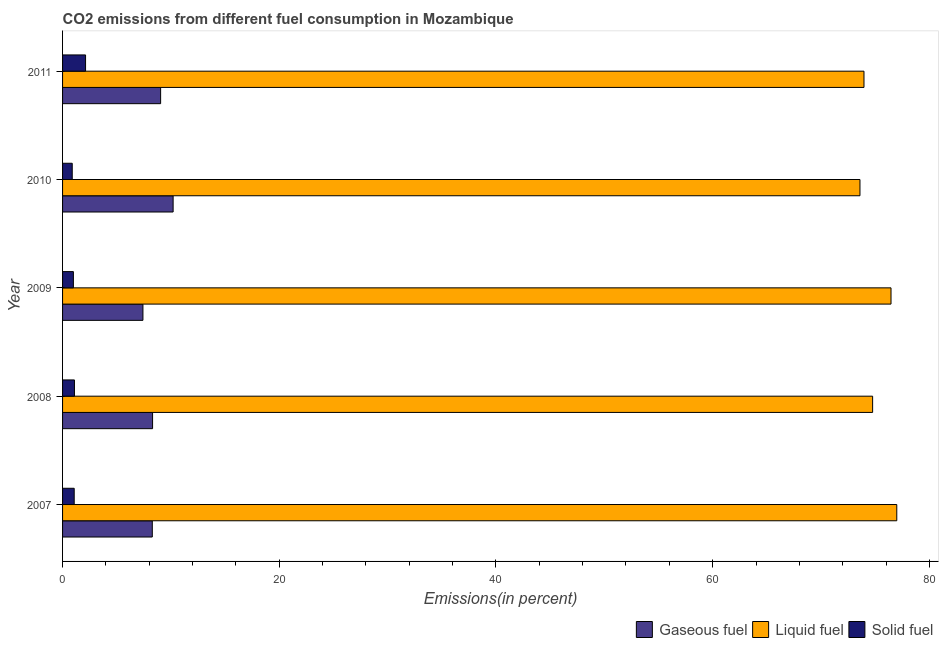Are the number of bars on each tick of the Y-axis equal?
Your answer should be compact. Yes. How many bars are there on the 3rd tick from the top?
Offer a very short reply. 3. How many bars are there on the 3rd tick from the bottom?
Make the answer very short. 3. What is the label of the 4th group of bars from the top?
Give a very brief answer. 2008. What is the percentage of solid fuel emission in 2007?
Provide a short and direct response. 1.07. Across all years, what is the maximum percentage of solid fuel emission?
Your answer should be very brief. 2.12. Across all years, what is the minimum percentage of solid fuel emission?
Ensure brevity in your answer.  0.89. In which year was the percentage of gaseous fuel emission maximum?
Offer a terse response. 2010. In which year was the percentage of solid fuel emission minimum?
Your answer should be compact. 2010. What is the total percentage of liquid fuel emission in the graph?
Your answer should be very brief. 375.78. What is the difference between the percentage of gaseous fuel emission in 2010 and that in 2011?
Offer a terse response. 1.15. What is the difference between the percentage of gaseous fuel emission in 2008 and the percentage of liquid fuel emission in 2011?
Provide a succinct answer. -65.66. What is the average percentage of gaseous fuel emission per year?
Offer a very short reply. 8.65. In the year 2009, what is the difference between the percentage of solid fuel emission and percentage of liquid fuel emission?
Offer a terse response. -75.46. What is the ratio of the percentage of solid fuel emission in 2009 to that in 2010?
Provide a short and direct response. 1.12. What is the difference between the highest and the second highest percentage of liquid fuel emission?
Make the answer very short. 0.53. What is the difference between the highest and the lowest percentage of gaseous fuel emission?
Ensure brevity in your answer.  2.79. In how many years, is the percentage of solid fuel emission greater than the average percentage of solid fuel emission taken over all years?
Your answer should be very brief. 1. What does the 2nd bar from the top in 2009 represents?
Offer a terse response. Liquid fuel. What does the 2nd bar from the bottom in 2008 represents?
Offer a very short reply. Liquid fuel. Are all the bars in the graph horizontal?
Offer a terse response. Yes. What is the difference between two consecutive major ticks on the X-axis?
Your response must be concise. 20. Are the values on the major ticks of X-axis written in scientific E-notation?
Give a very brief answer. No. Does the graph contain any zero values?
Make the answer very short. No. Does the graph contain grids?
Ensure brevity in your answer.  No. How many legend labels are there?
Offer a terse response. 3. What is the title of the graph?
Offer a terse response. CO2 emissions from different fuel consumption in Mozambique. Does "Taxes on goods and services" appear as one of the legend labels in the graph?
Provide a succinct answer. No. What is the label or title of the X-axis?
Your response must be concise. Emissions(in percent). What is the label or title of the Y-axis?
Provide a short and direct response. Year. What is the Emissions(in percent) in Gaseous fuel in 2007?
Offer a very short reply. 8.28. What is the Emissions(in percent) of Liquid fuel in 2007?
Offer a terse response. 76.99. What is the Emissions(in percent) in Solid fuel in 2007?
Offer a very short reply. 1.07. What is the Emissions(in percent) of Gaseous fuel in 2008?
Provide a short and direct response. 8.31. What is the Emissions(in percent) of Liquid fuel in 2008?
Offer a very short reply. 74.76. What is the Emissions(in percent) in Solid fuel in 2008?
Provide a succinct answer. 1.1. What is the Emissions(in percent) of Gaseous fuel in 2009?
Provide a succinct answer. 7.42. What is the Emissions(in percent) in Liquid fuel in 2009?
Provide a short and direct response. 76.46. What is the Emissions(in percent) in Solid fuel in 2009?
Your answer should be very brief. 1. What is the Emissions(in percent) of Gaseous fuel in 2010?
Ensure brevity in your answer.  10.2. What is the Emissions(in percent) in Liquid fuel in 2010?
Provide a short and direct response. 73.6. What is the Emissions(in percent) in Solid fuel in 2010?
Your answer should be compact. 0.89. What is the Emissions(in percent) in Gaseous fuel in 2011?
Your response must be concise. 9.05. What is the Emissions(in percent) of Liquid fuel in 2011?
Give a very brief answer. 73.97. What is the Emissions(in percent) in Solid fuel in 2011?
Offer a terse response. 2.12. Across all years, what is the maximum Emissions(in percent) of Gaseous fuel?
Your response must be concise. 10.2. Across all years, what is the maximum Emissions(in percent) in Liquid fuel?
Give a very brief answer. 76.99. Across all years, what is the maximum Emissions(in percent) of Solid fuel?
Make the answer very short. 2.12. Across all years, what is the minimum Emissions(in percent) in Gaseous fuel?
Provide a short and direct response. 7.42. Across all years, what is the minimum Emissions(in percent) in Liquid fuel?
Your answer should be compact. 73.6. Across all years, what is the minimum Emissions(in percent) in Solid fuel?
Provide a succinct answer. 0.89. What is the total Emissions(in percent) of Gaseous fuel in the graph?
Give a very brief answer. 43.26. What is the total Emissions(in percent) in Liquid fuel in the graph?
Your response must be concise. 375.78. What is the total Emissions(in percent) in Solid fuel in the graph?
Keep it short and to the point. 6.19. What is the difference between the Emissions(in percent) in Gaseous fuel in 2007 and that in 2008?
Make the answer very short. -0.03. What is the difference between the Emissions(in percent) of Liquid fuel in 2007 and that in 2008?
Offer a very short reply. 2.23. What is the difference between the Emissions(in percent) in Solid fuel in 2007 and that in 2008?
Provide a short and direct response. -0.02. What is the difference between the Emissions(in percent) in Gaseous fuel in 2007 and that in 2009?
Make the answer very short. 0.86. What is the difference between the Emissions(in percent) of Liquid fuel in 2007 and that in 2009?
Your response must be concise. 0.53. What is the difference between the Emissions(in percent) in Solid fuel in 2007 and that in 2009?
Keep it short and to the point. 0.07. What is the difference between the Emissions(in percent) in Gaseous fuel in 2007 and that in 2010?
Keep it short and to the point. -1.92. What is the difference between the Emissions(in percent) of Liquid fuel in 2007 and that in 2010?
Keep it short and to the point. 3.4. What is the difference between the Emissions(in percent) in Solid fuel in 2007 and that in 2010?
Make the answer very short. 0.18. What is the difference between the Emissions(in percent) of Gaseous fuel in 2007 and that in 2011?
Your answer should be compact. -0.77. What is the difference between the Emissions(in percent) of Liquid fuel in 2007 and that in 2011?
Provide a short and direct response. 3.03. What is the difference between the Emissions(in percent) in Solid fuel in 2007 and that in 2011?
Your answer should be very brief. -1.05. What is the difference between the Emissions(in percent) of Gaseous fuel in 2008 and that in 2009?
Make the answer very short. 0.89. What is the difference between the Emissions(in percent) of Liquid fuel in 2008 and that in 2009?
Your answer should be compact. -1.7. What is the difference between the Emissions(in percent) of Solid fuel in 2008 and that in 2009?
Offer a terse response. 0.1. What is the difference between the Emissions(in percent) in Gaseous fuel in 2008 and that in 2010?
Offer a terse response. -1.9. What is the difference between the Emissions(in percent) in Liquid fuel in 2008 and that in 2010?
Keep it short and to the point. 1.17. What is the difference between the Emissions(in percent) in Solid fuel in 2008 and that in 2010?
Provide a short and direct response. 0.2. What is the difference between the Emissions(in percent) of Gaseous fuel in 2008 and that in 2011?
Ensure brevity in your answer.  -0.74. What is the difference between the Emissions(in percent) in Liquid fuel in 2008 and that in 2011?
Keep it short and to the point. 0.8. What is the difference between the Emissions(in percent) of Solid fuel in 2008 and that in 2011?
Provide a short and direct response. -1.03. What is the difference between the Emissions(in percent) of Gaseous fuel in 2009 and that in 2010?
Your response must be concise. -2.79. What is the difference between the Emissions(in percent) in Liquid fuel in 2009 and that in 2010?
Offer a terse response. 2.87. What is the difference between the Emissions(in percent) of Solid fuel in 2009 and that in 2010?
Keep it short and to the point. 0.11. What is the difference between the Emissions(in percent) in Gaseous fuel in 2009 and that in 2011?
Keep it short and to the point. -1.63. What is the difference between the Emissions(in percent) in Liquid fuel in 2009 and that in 2011?
Keep it short and to the point. 2.5. What is the difference between the Emissions(in percent) of Solid fuel in 2009 and that in 2011?
Offer a terse response. -1.12. What is the difference between the Emissions(in percent) of Gaseous fuel in 2010 and that in 2011?
Offer a terse response. 1.15. What is the difference between the Emissions(in percent) of Liquid fuel in 2010 and that in 2011?
Your response must be concise. -0.37. What is the difference between the Emissions(in percent) in Solid fuel in 2010 and that in 2011?
Your answer should be compact. -1.23. What is the difference between the Emissions(in percent) of Gaseous fuel in 2007 and the Emissions(in percent) of Liquid fuel in 2008?
Keep it short and to the point. -66.48. What is the difference between the Emissions(in percent) of Gaseous fuel in 2007 and the Emissions(in percent) of Solid fuel in 2008?
Your answer should be very brief. 7.18. What is the difference between the Emissions(in percent) of Liquid fuel in 2007 and the Emissions(in percent) of Solid fuel in 2008?
Your answer should be compact. 75.9. What is the difference between the Emissions(in percent) in Gaseous fuel in 2007 and the Emissions(in percent) in Liquid fuel in 2009?
Offer a terse response. -68.18. What is the difference between the Emissions(in percent) in Gaseous fuel in 2007 and the Emissions(in percent) in Solid fuel in 2009?
Keep it short and to the point. 7.28. What is the difference between the Emissions(in percent) of Liquid fuel in 2007 and the Emissions(in percent) of Solid fuel in 2009?
Your answer should be very brief. 76. What is the difference between the Emissions(in percent) of Gaseous fuel in 2007 and the Emissions(in percent) of Liquid fuel in 2010?
Keep it short and to the point. -65.31. What is the difference between the Emissions(in percent) in Gaseous fuel in 2007 and the Emissions(in percent) in Solid fuel in 2010?
Make the answer very short. 7.39. What is the difference between the Emissions(in percent) of Liquid fuel in 2007 and the Emissions(in percent) of Solid fuel in 2010?
Offer a very short reply. 76.1. What is the difference between the Emissions(in percent) of Gaseous fuel in 2007 and the Emissions(in percent) of Liquid fuel in 2011?
Offer a very short reply. -65.68. What is the difference between the Emissions(in percent) in Gaseous fuel in 2007 and the Emissions(in percent) in Solid fuel in 2011?
Provide a short and direct response. 6.16. What is the difference between the Emissions(in percent) in Liquid fuel in 2007 and the Emissions(in percent) in Solid fuel in 2011?
Keep it short and to the point. 74.87. What is the difference between the Emissions(in percent) in Gaseous fuel in 2008 and the Emissions(in percent) in Liquid fuel in 2009?
Offer a very short reply. -68.16. What is the difference between the Emissions(in percent) of Gaseous fuel in 2008 and the Emissions(in percent) of Solid fuel in 2009?
Make the answer very short. 7.31. What is the difference between the Emissions(in percent) of Liquid fuel in 2008 and the Emissions(in percent) of Solid fuel in 2009?
Your response must be concise. 73.77. What is the difference between the Emissions(in percent) in Gaseous fuel in 2008 and the Emissions(in percent) in Liquid fuel in 2010?
Give a very brief answer. -65.29. What is the difference between the Emissions(in percent) of Gaseous fuel in 2008 and the Emissions(in percent) of Solid fuel in 2010?
Make the answer very short. 7.41. What is the difference between the Emissions(in percent) in Liquid fuel in 2008 and the Emissions(in percent) in Solid fuel in 2010?
Make the answer very short. 73.87. What is the difference between the Emissions(in percent) in Gaseous fuel in 2008 and the Emissions(in percent) in Liquid fuel in 2011?
Your response must be concise. -65.66. What is the difference between the Emissions(in percent) in Gaseous fuel in 2008 and the Emissions(in percent) in Solid fuel in 2011?
Keep it short and to the point. 6.18. What is the difference between the Emissions(in percent) of Liquid fuel in 2008 and the Emissions(in percent) of Solid fuel in 2011?
Ensure brevity in your answer.  72.64. What is the difference between the Emissions(in percent) in Gaseous fuel in 2009 and the Emissions(in percent) in Liquid fuel in 2010?
Offer a terse response. -66.18. What is the difference between the Emissions(in percent) in Gaseous fuel in 2009 and the Emissions(in percent) in Solid fuel in 2010?
Keep it short and to the point. 6.53. What is the difference between the Emissions(in percent) of Liquid fuel in 2009 and the Emissions(in percent) of Solid fuel in 2010?
Offer a terse response. 75.57. What is the difference between the Emissions(in percent) of Gaseous fuel in 2009 and the Emissions(in percent) of Liquid fuel in 2011?
Keep it short and to the point. -66.55. What is the difference between the Emissions(in percent) of Gaseous fuel in 2009 and the Emissions(in percent) of Solid fuel in 2011?
Ensure brevity in your answer.  5.3. What is the difference between the Emissions(in percent) in Liquid fuel in 2009 and the Emissions(in percent) in Solid fuel in 2011?
Offer a very short reply. 74.34. What is the difference between the Emissions(in percent) of Gaseous fuel in 2010 and the Emissions(in percent) of Liquid fuel in 2011?
Give a very brief answer. -63.76. What is the difference between the Emissions(in percent) of Gaseous fuel in 2010 and the Emissions(in percent) of Solid fuel in 2011?
Keep it short and to the point. 8.08. What is the difference between the Emissions(in percent) of Liquid fuel in 2010 and the Emissions(in percent) of Solid fuel in 2011?
Your answer should be very brief. 71.47. What is the average Emissions(in percent) in Gaseous fuel per year?
Your answer should be compact. 8.65. What is the average Emissions(in percent) in Liquid fuel per year?
Make the answer very short. 75.16. What is the average Emissions(in percent) in Solid fuel per year?
Keep it short and to the point. 1.24. In the year 2007, what is the difference between the Emissions(in percent) in Gaseous fuel and Emissions(in percent) in Liquid fuel?
Your response must be concise. -68.71. In the year 2007, what is the difference between the Emissions(in percent) in Gaseous fuel and Emissions(in percent) in Solid fuel?
Offer a very short reply. 7.21. In the year 2007, what is the difference between the Emissions(in percent) of Liquid fuel and Emissions(in percent) of Solid fuel?
Give a very brief answer. 75.92. In the year 2008, what is the difference between the Emissions(in percent) of Gaseous fuel and Emissions(in percent) of Liquid fuel?
Keep it short and to the point. -66.46. In the year 2008, what is the difference between the Emissions(in percent) in Gaseous fuel and Emissions(in percent) in Solid fuel?
Offer a very short reply. 7.21. In the year 2008, what is the difference between the Emissions(in percent) of Liquid fuel and Emissions(in percent) of Solid fuel?
Make the answer very short. 73.67. In the year 2009, what is the difference between the Emissions(in percent) of Gaseous fuel and Emissions(in percent) of Liquid fuel?
Give a very brief answer. -69.04. In the year 2009, what is the difference between the Emissions(in percent) of Gaseous fuel and Emissions(in percent) of Solid fuel?
Your answer should be compact. 6.42. In the year 2009, what is the difference between the Emissions(in percent) in Liquid fuel and Emissions(in percent) in Solid fuel?
Keep it short and to the point. 75.46. In the year 2010, what is the difference between the Emissions(in percent) of Gaseous fuel and Emissions(in percent) of Liquid fuel?
Keep it short and to the point. -63.39. In the year 2010, what is the difference between the Emissions(in percent) of Gaseous fuel and Emissions(in percent) of Solid fuel?
Offer a very short reply. 9.31. In the year 2010, what is the difference between the Emissions(in percent) of Liquid fuel and Emissions(in percent) of Solid fuel?
Offer a terse response. 72.7. In the year 2011, what is the difference between the Emissions(in percent) in Gaseous fuel and Emissions(in percent) in Liquid fuel?
Offer a very short reply. -64.92. In the year 2011, what is the difference between the Emissions(in percent) of Gaseous fuel and Emissions(in percent) of Solid fuel?
Offer a very short reply. 6.93. In the year 2011, what is the difference between the Emissions(in percent) of Liquid fuel and Emissions(in percent) of Solid fuel?
Your answer should be compact. 71.84. What is the ratio of the Emissions(in percent) of Gaseous fuel in 2007 to that in 2008?
Your answer should be compact. 1. What is the ratio of the Emissions(in percent) of Liquid fuel in 2007 to that in 2008?
Your answer should be very brief. 1.03. What is the ratio of the Emissions(in percent) in Solid fuel in 2007 to that in 2008?
Provide a short and direct response. 0.98. What is the ratio of the Emissions(in percent) in Gaseous fuel in 2007 to that in 2009?
Your response must be concise. 1.12. What is the ratio of the Emissions(in percent) in Solid fuel in 2007 to that in 2009?
Provide a short and direct response. 1.08. What is the ratio of the Emissions(in percent) in Gaseous fuel in 2007 to that in 2010?
Your answer should be compact. 0.81. What is the ratio of the Emissions(in percent) of Liquid fuel in 2007 to that in 2010?
Offer a very short reply. 1.05. What is the ratio of the Emissions(in percent) of Solid fuel in 2007 to that in 2010?
Your response must be concise. 1.2. What is the ratio of the Emissions(in percent) of Gaseous fuel in 2007 to that in 2011?
Ensure brevity in your answer.  0.92. What is the ratio of the Emissions(in percent) in Liquid fuel in 2007 to that in 2011?
Make the answer very short. 1.04. What is the ratio of the Emissions(in percent) of Solid fuel in 2007 to that in 2011?
Provide a succinct answer. 0.51. What is the ratio of the Emissions(in percent) in Gaseous fuel in 2008 to that in 2009?
Ensure brevity in your answer.  1.12. What is the ratio of the Emissions(in percent) in Liquid fuel in 2008 to that in 2009?
Your response must be concise. 0.98. What is the ratio of the Emissions(in percent) of Solid fuel in 2008 to that in 2009?
Provide a short and direct response. 1.1. What is the ratio of the Emissions(in percent) in Gaseous fuel in 2008 to that in 2010?
Your answer should be compact. 0.81. What is the ratio of the Emissions(in percent) in Liquid fuel in 2008 to that in 2010?
Give a very brief answer. 1.02. What is the ratio of the Emissions(in percent) of Solid fuel in 2008 to that in 2010?
Provide a succinct answer. 1.23. What is the ratio of the Emissions(in percent) of Gaseous fuel in 2008 to that in 2011?
Your response must be concise. 0.92. What is the ratio of the Emissions(in percent) in Liquid fuel in 2008 to that in 2011?
Make the answer very short. 1.01. What is the ratio of the Emissions(in percent) of Solid fuel in 2008 to that in 2011?
Provide a succinct answer. 0.52. What is the ratio of the Emissions(in percent) in Gaseous fuel in 2009 to that in 2010?
Give a very brief answer. 0.73. What is the ratio of the Emissions(in percent) of Liquid fuel in 2009 to that in 2010?
Your answer should be compact. 1.04. What is the ratio of the Emissions(in percent) of Solid fuel in 2009 to that in 2010?
Your answer should be very brief. 1.12. What is the ratio of the Emissions(in percent) in Gaseous fuel in 2009 to that in 2011?
Provide a succinct answer. 0.82. What is the ratio of the Emissions(in percent) in Liquid fuel in 2009 to that in 2011?
Your response must be concise. 1.03. What is the ratio of the Emissions(in percent) of Solid fuel in 2009 to that in 2011?
Offer a terse response. 0.47. What is the ratio of the Emissions(in percent) in Gaseous fuel in 2010 to that in 2011?
Make the answer very short. 1.13. What is the ratio of the Emissions(in percent) of Solid fuel in 2010 to that in 2011?
Give a very brief answer. 0.42. What is the difference between the highest and the second highest Emissions(in percent) of Gaseous fuel?
Offer a very short reply. 1.15. What is the difference between the highest and the second highest Emissions(in percent) of Liquid fuel?
Provide a short and direct response. 0.53. What is the difference between the highest and the second highest Emissions(in percent) in Solid fuel?
Give a very brief answer. 1.03. What is the difference between the highest and the lowest Emissions(in percent) of Gaseous fuel?
Your response must be concise. 2.79. What is the difference between the highest and the lowest Emissions(in percent) in Liquid fuel?
Make the answer very short. 3.4. What is the difference between the highest and the lowest Emissions(in percent) of Solid fuel?
Make the answer very short. 1.23. 